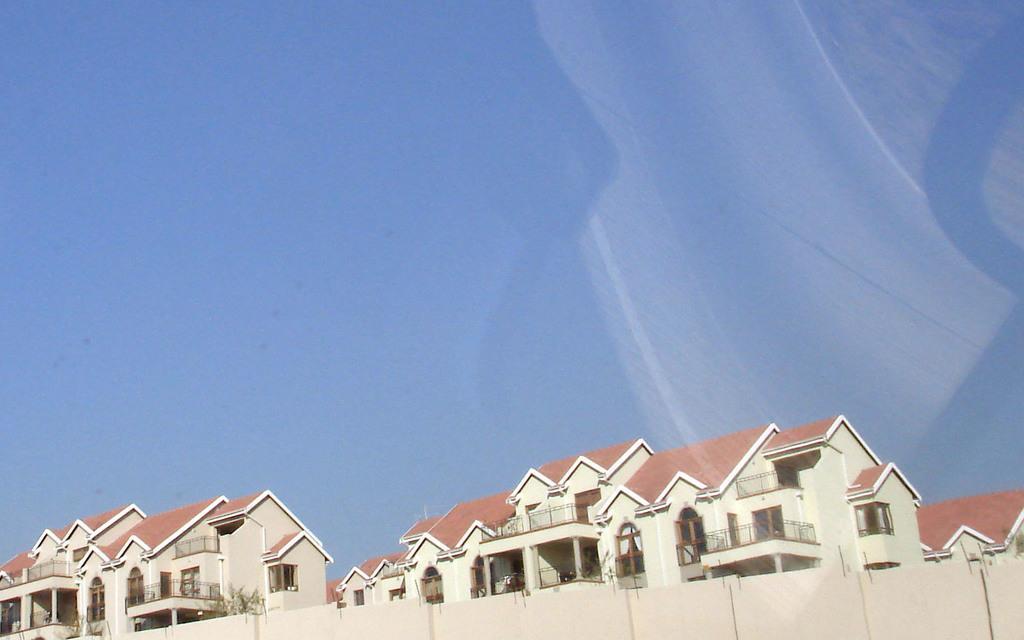Can you describe this image briefly? In this picture there are houses and there are plants. 